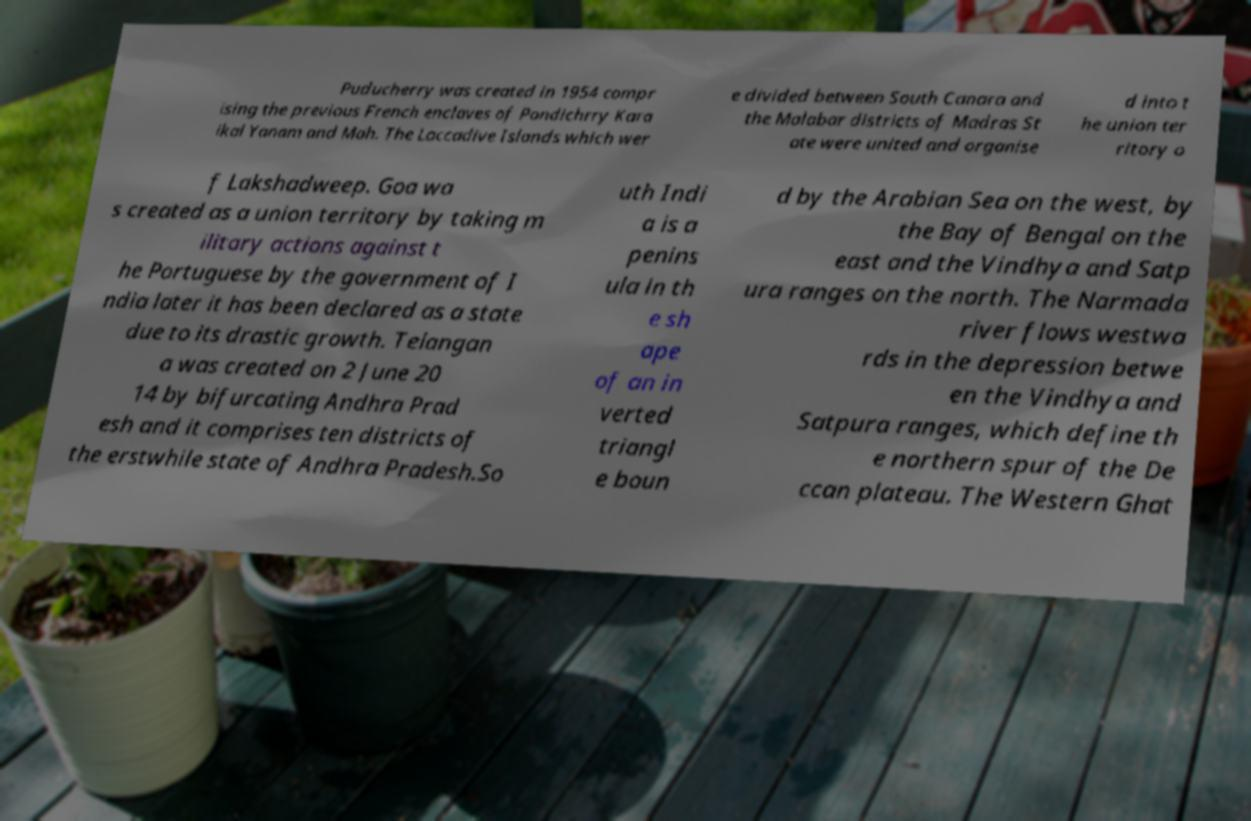Please identify and transcribe the text found in this image. Puducherry was created in 1954 compr ising the previous French enclaves of Pondichrry Kara ikal Yanam and Mah. The Laccadive Islands which wer e divided between South Canara and the Malabar districts of Madras St ate were united and organise d into t he union ter ritory o f Lakshadweep. Goa wa s created as a union territory by taking m ilitary actions against t he Portuguese by the government of I ndia later it has been declared as a state due to its drastic growth. Telangan a was created on 2 June 20 14 by bifurcating Andhra Prad esh and it comprises ten districts of the erstwhile state of Andhra Pradesh.So uth Indi a is a penins ula in th e sh ape of an in verted triangl e boun d by the Arabian Sea on the west, by the Bay of Bengal on the east and the Vindhya and Satp ura ranges on the north. The Narmada river flows westwa rds in the depression betwe en the Vindhya and Satpura ranges, which define th e northern spur of the De ccan plateau. The Western Ghat 